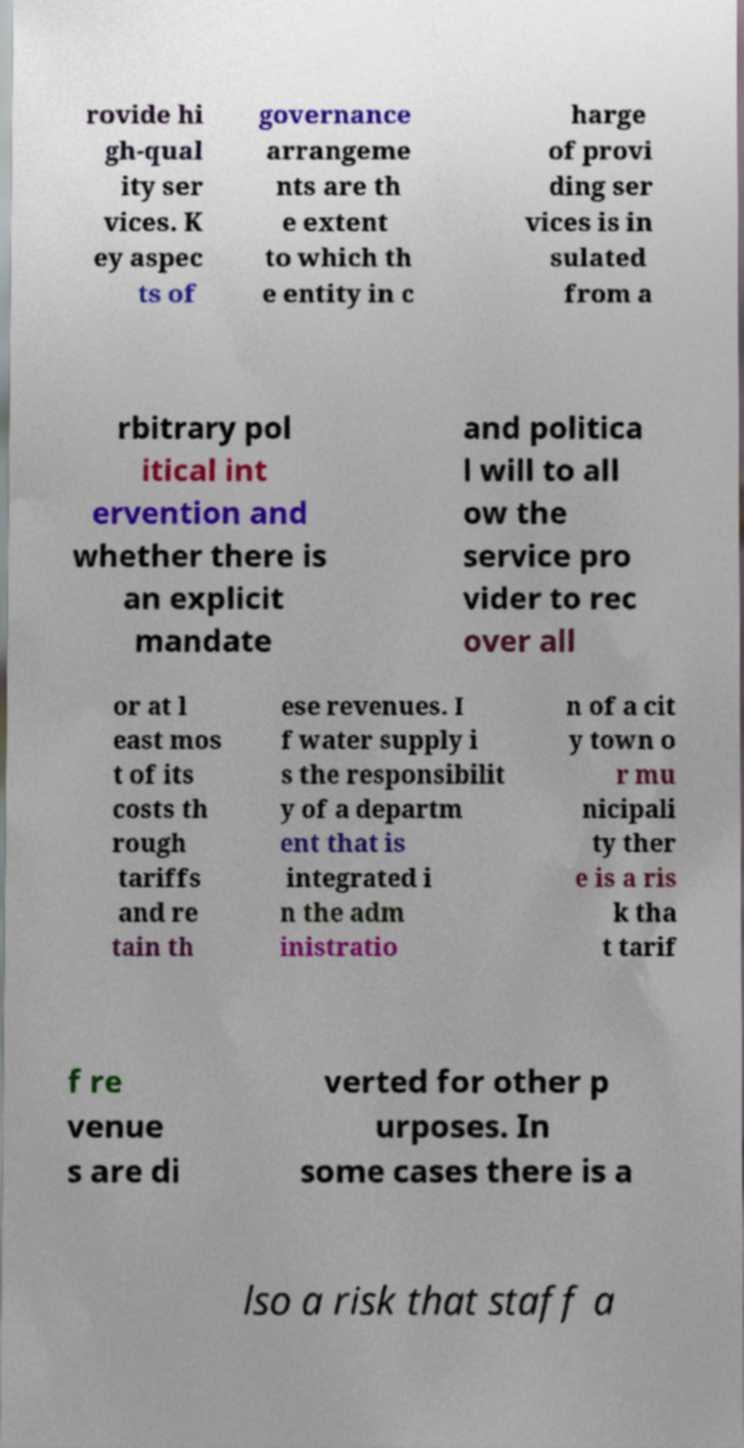Could you extract and type out the text from this image? rovide hi gh-qual ity ser vices. K ey aspec ts of governance arrangeme nts are th e extent to which th e entity in c harge of provi ding ser vices is in sulated from a rbitrary pol itical int ervention and whether there is an explicit mandate and politica l will to all ow the service pro vider to rec over all or at l east mos t of its costs th rough tariffs and re tain th ese revenues. I f water supply i s the responsibilit y of a departm ent that is integrated i n the adm inistratio n of a cit y town o r mu nicipali ty ther e is a ris k tha t tarif f re venue s are di verted for other p urposes. In some cases there is a lso a risk that staff a 